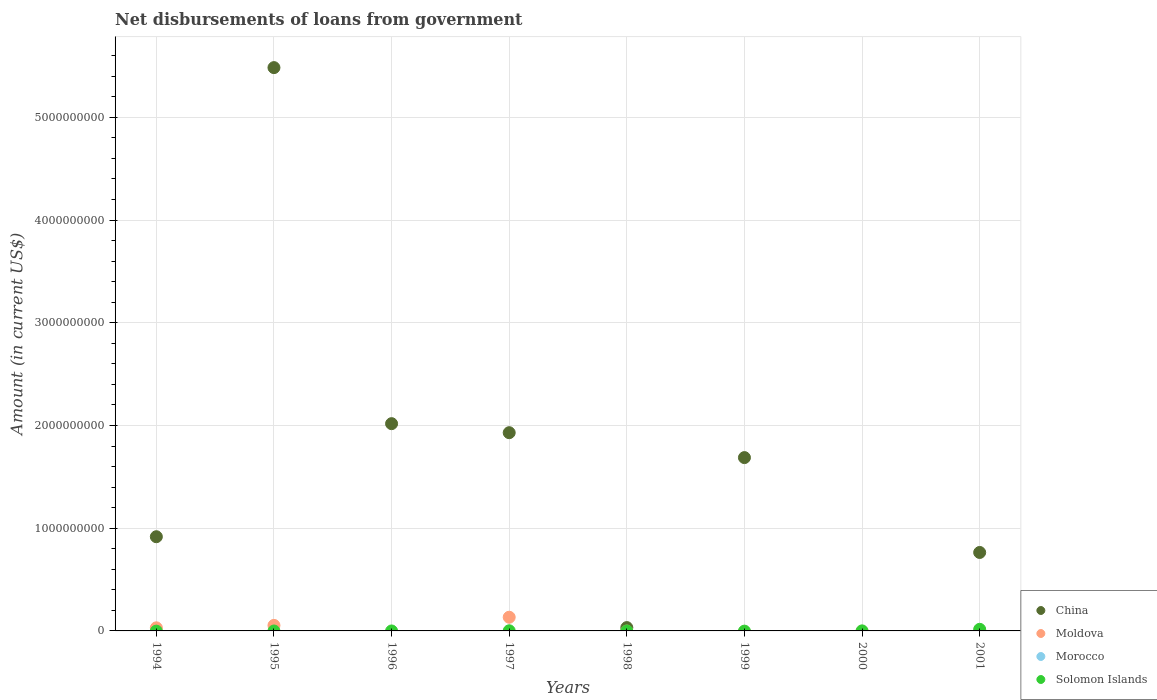Across all years, what is the maximum amount of loan disbursed from government in Moldova?
Provide a succinct answer. 1.33e+08. What is the total amount of loan disbursed from government in Moldova in the graph?
Make the answer very short. 2.17e+08. What is the difference between the amount of loan disbursed from government in Moldova in 1994 and that in 1997?
Make the answer very short. -1.03e+08. What is the difference between the amount of loan disbursed from government in China in 1998 and the amount of loan disbursed from government in Solomon Islands in 1997?
Make the answer very short. 3.10e+07. What is the average amount of loan disbursed from government in Morocco per year?
Your answer should be very brief. 0. In the year 1994, what is the difference between the amount of loan disbursed from government in China and amount of loan disbursed from government in Moldova?
Offer a terse response. 8.87e+08. Is the difference between the amount of loan disbursed from government in China in 1994 and 1997 greater than the difference between the amount of loan disbursed from government in Moldova in 1994 and 1997?
Make the answer very short. No. What is the difference between the highest and the second highest amount of loan disbursed from government in Solomon Islands?
Ensure brevity in your answer.  1.43e+07. What is the difference between the highest and the lowest amount of loan disbursed from government in Solomon Islands?
Your answer should be very brief. 1.57e+07. In how many years, is the amount of loan disbursed from government in China greater than the average amount of loan disbursed from government in China taken over all years?
Offer a terse response. 4. Is it the case that in every year, the sum of the amount of loan disbursed from government in Morocco and amount of loan disbursed from government in China  is greater than the sum of amount of loan disbursed from government in Solomon Islands and amount of loan disbursed from government in Moldova?
Offer a terse response. No. Is the amount of loan disbursed from government in Moldova strictly greater than the amount of loan disbursed from government in Morocco over the years?
Offer a terse response. Yes. Are the values on the major ticks of Y-axis written in scientific E-notation?
Provide a succinct answer. No. How many legend labels are there?
Ensure brevity in your answer.  4. How are the legend labels stacked?
Ensure brevity in your answer.  Vertical. What is the title of the graph?
Your answer should be compact. Net disbursements of loans from government. Does "El Salvador" appear as one of the legend labels in the graph?
Your answer should be compact. No. What is the label or title of the Y-axis?
Offer a terse response. Amount (in current US$). What is the Amount (in current US$) of China in 1994?
Offer a terse response. 9.17e+08. What is the Amount (in current US$) of Moldova in 1994?
Offer a very short reply. 3.01e+07. What is the Amount (in current US$) in Morocco in 1994?
Ensure brevity in your answer.  0. What is the Amount (in current US$) in Solomon Islands in 1994?
Provide a short and direct response. 0. What is the Amount (in current US$) in China in 1995?
Offer a terse response. 5.48e+09. What is the Amount (in current US$) of Moldova in 1995?
Offer a very short reply. 5.38e+07. What is the Amount (in current US$) in Morocco in 1995?
Give a very brief answer. 0. What is the Amount (in current US$) in China in 1996?
Provide a short and direct response. 2.02e+09. What is the Amount (in current US$) in Moldova in 1996?
Your response must be concise. 0. What is the Amount (in current US$) of China in 1997?
Offer a terse response. 1.93e+09. What is the Amount (in current US$) of Moldova in 1997?
Provide a short and direct response. 1.33e+08. What is the Amount (in current US$) in Morocco in 1997?
Your response must be concise. 0. What is the Amount (in current US$) of Solomon Islands in 1997?
Provide a succinct answer. 1.36e+06. What is the Amount (in current US$) of China in 1998?
Your response must be concise. 3.24e+07. What is the Amount (in current US$) of Morocco in 1998?
Your response must be concise. 0. What is the Amount (in current US$) in Solomon Islands in 1998?
Offer a very short reply. 0. What is the Amount (in current US$) in China in 1999?
Offer a terse response. 1.69e+09. What is the Amount (in current US$) of Morocco in 1999?
Ensure brevity in your answer.  0. What is the Amount (in current US$) of Solomon Islands in 1999?
Keep it short and to the point. 0. What is the Amount (in current US$) in China in 2000?
Give a very brief answer. 0. What is the Amount (in current US$) in Moldova in 2000?
Provide a succinct answer. 0. What is the Amount (in current US$) in Solomon Islands in 2000?
Offer a very short reply. 3.48e+05. What is the Amount (in current US$) in China in 2001?
Give a very brief answer. 7.64e+08. What is the Amount (in current US$) in Moldova in 2001?
Ensure brevity in your answer.  0. What is the Amount (in current US$) in Morocco in 2001?
Offer a very short reply. 0. What is the Amount (in current US$) of Solomon Islands in 2001?
Your answer should be compact. 1.57e+07. Across all years, what is the maximum Amount (in current US$) of China?
Give a very brief answer. 5.48e+09. Across all years, what is the maximum Amount (in current US$) of Moldova?
Make the answer very short. 1.33e+08. Across all years, what is the maximum Amount (in current US$) in Solomon Islands?
Provide a succinct answer. 1.57e+07. Across all years, what is the minimum Amount (in current US$) in China?
Offer a very short reply. 0. Across all years, what is the minimum Amount (in current US$) of Solomon Islands?
Your answer should be compact. 0. What is the total Amount (in current US$) of China in the graph?
Offer a terse response. 1.28e+1. What is the total Amount (in current US$) of Moldova in the graph?
Provide a succinct answer. 2.17e+08. What is the total Amount (in current US$) of Morocco in the graph?
Your response must be concise. 0. What is the total Amount (in current US$) of Solomon Islands in the graph?
Offer a terse response. 1.74e+07. What is the difference between the Amount (in current US$) in China in 1994 and that in 1995?
Offer a terse response. -4.57e+09. What is the difference between the Amount (in current US$) of Moldova in 1994 and that in 1995?
Give a very brief answer. -2.38e+07. What is the difference between the Amount (in current US$) of China in 1994 and that in 1996?
Provide a short and direct response. -1.10e+09. What is the difference between the Amount (in current US$) in China in 1994 and that in 1997?
Your answer should be very brief. -1.01e+09. What is the difference between the Amount (in current US$) in Moldova in 1994 and that in 1997?
Your response must be concise. -1.03e+08. What is the difference between the Amount (in current US$) in China in 1994 and that in 1998?
Ensure brevity in your answer.  8.85e+08. What is the difference between the Amount (in current US$) in China in 1994 and that in 1999?
Ensure brevity in your answer.  -7.70e+08. What is the difference between the Amount (in current US$) of China in 1994 and that in 2001?
Your answer should be compact. 1.53e+08. What is the difference between the Amount (in current US$) of China in 1995 and that in 1996?
Give a very brief answer. 3.47e+09. What is the difference between the Amount (in current US$) in China in 1995 and that in 1997?
Make the answer very short. 3.55e+09. What is the difference between the Amount (in current US$) in Moldova in 1995 and that in 1997?
Offer a very short reply. -7.94e+07. What is the difference between the Amount (in current US$) in China in 1995 and that in 1998?
Your answer should be very brief. 5.45e+09. What is the difference between the Amount (in current US$) of China in 1995 and that in 1999?
Provide a short and direct response. 3.80e+09. What is the difference between the Amount (in current US$) in China in 1995 and that in 2001?
Provide a short and direct response. 4.72e+09. What is the difference between the Amount (in current US$) of China in 1996 and that in 1997?
Provide a succinct answer. 8.78e+07. What is the difference between the Amount (in current US$) in China in 1996 and that in 1998?
Make the answer very short. 1.99e+09. What is the difference between the Amount (in current US$) in China in 1996 and that in 1999?
Provide a short and direct response. 3.30e+08. What is the difference between the Amount (in current US$) in China in 1996 and that in 2001?
Give a very brief answer. 1.25e+09. What is the difference between the Amount (in current US$) of China in 1997 and that in 1998?
Offer a terse response. 1.90e+09. What is the difference between the Amount (in current US$) of China in 1997 and that in 1999?
Make the answer very short. 2.43e+08. What is the difference between the Amount (in current US$) of Solomon Islands in 1997 and that in 2000?
Ensure brevity in your answer.  1.01e+06. What is the difference between the Amount (in current US$) of China in 1997 and that in 2001?
Make the answer very short. 1.17e+09. What is the difference between the Amount (in current US$) of Solomon Islands in 1997 and that in 2001?
Provide a short and direct response. -1.43e+07. What is the difference between the Amount (in current US$) of China in 1998 and that in 1999?
Provide a succinct answer. -1.66e+09. What is the difference between the Amount (in current US$) of China in 1998 and that in 2001?
Offer a terse response. -7.31e+08. What is the difference between the Amount (in current US$) of China in 1999 and that in 2001?
Your response must be concise. 9.24e+08. What is the difference between the Amount (in current US$) of Solomon Islands in 2000 and that in 2001?
Provide a succinct answer. -1.53e+07. What is the difference between the Amount (in current US$) of China in 1994 and the Amount (in current US$) of Moldova in 1995?
Your answer should be very brief. 8.63e+08. What is the difference between the Amount (in current US$) in China in 1994 and the Amount (in current US$) in Moldova in 1997?
Your answer should be compact. 7.84e+08. What is the difference between the Amount (in current US$) in China in 1994 and the Amount (in current US$) in Solomon Islands in 1997?
Provide a succinct answer. 9.16e+08. What is the difference between the Amount (in current US$) in Moldova in 1994 and the Amount (in current US$) in Solomon Islands in 1997?
Provide a short and direct response. 2.87e+07. What is the difference between the Amount (in current US$) of China in 1994 and the Amount (in current US$) of Solomon Islands in 2000?
Your answer should be very brief. 9.17e+08. What is the difference between the Amount (in current US$) of Moldova in 1994 and the Amount (in current US$) of Solomon Islands in 2000?
Keep it short and to the point. 2.97e+07. What is the difference between the Amount (in current US$) in China in 1994 and the Amount (in current US$) in Solomon Islands in 2001?
Give a very brief answer. 9.01e+08. What is the difference between the Amount (in current US$) in Moldova in 1994 and the Amount (in current US$) in Solomon Islands in 2001?
Your response must be concise. 1.44e+07. What is the difference between the Amount (in current US$) in China in 1995 and the Amount (in current US$) in Moldova in 1997?
Give a very brief answer. 5.35e+09. What is the difference between the Amount (in current US$) of China in 1995 and the Amount (in current US$) of Solomon Islands in 1997?
Give a very brief answer. 5.48e+09. What is the difference between the Amount (in current US$) of Moldova in 1995 and the Amount (in current US$) of Solomon Islands in 1997?
Give a very brief answer. 5.25e+07. What is the difference between the Amount (in current US$) in China in 1995 and the Amount (in current US$) in Solomon Islands in 2000?
Offer a terse response. 5.48e+09. What is the difference between the Amount (in current US$) in Moldova in 1995 and the Amount (in current US$) in Solomon Islands in 2000?
Make the answer very short. 5.35e+07. What is the difference between the Amount (in current US$) of China in 1995 and the Amount (in current US$) of Solomon Islands in 2001?
Offer a terse response. 5.47e+09. What is the difference between the Amount (in current US$) of Moldova in 1995 and the Amount (in current US$) of Solomon Islands in 2001?
Provide a short and direct response. 3.82e+07. What is the difference between the Amount (in current US$) in China in 1996 and the Amount (in current US$) in Moldova in 1997?
Keep it short and to the point. 1.88e+09. What is the difference between the Amount (in current US$) of China in 1996 and the Amount (in current US$) of Solomon Islands in 1997?
Provide a short and direct response. 2.02e+09. What is the difference between the Amount (in current US$) of China in 1996 and the Amount (in current US$) of Solomon Islands in 2000?
Provide a short and direct response. 2.02e+09. What is the difference between the Amount (in current US$) in China in 1996 and the Amount (in current US$) in Solomon Islands in 2001?
Your answer should be very brief. 2.00e+09. What is the difference between the Amount (in current US$) in China in 1997 and the Amount (in current US$) in Solomon Islands in 2000?
Ensure brevity in your answer.  1.93e+09. What is the difference between the Amount (in current US$) of Moldova in 1997 and the Amount (in current US$) of Solomon Islands in 2000?
Give a very brief answer. 1.33e+08. What is the difference between the Amount (in current US$) of China in 1997 and the Amount (in current US$) of Solomon Islands in 2001?
Keep it short and to the point. 1.91e+09. What is the difference between the Amount (in current US$) of Moldova in 1997 and the Amount (in current US$) of Solomon Islands in 2001?
Keep it short and to the point. 1.18e+08. What is the difference between the Amount (in current US$) in China in 1998 and the Amount (in current US$) in Solomon Islands in 2000?
Your answer should be compact. 3.20e+07. What is the difference between the Amount (in current US$) in China in 1998 and the Amount (in current US$) in Solomon Islands in 2001?
Provide a succinct answer. 1.67e+07. What is the difference between the Amount (in current US$) of China in 1999 and the Amount (in current US$) of Solomon Islands in 2000?
Ensure brevity in your answer.  1.69e+09. What is the difference between the Amount (in current US$) in China in 1999 and the Amount (in current US$) in Solomon Islands in 2001?
Offer a very short reply. 1.67e+09. What is the average Amount (in current US$) of China per year?
Your answer should be compact. 1.60e+09. What is the average Amount (in current US$) of Moldova per year?
Ensure brevity in your answer.  2.71e+07. What is the average Amount (in current US$) of Solomon Islands per year?
Ensure brevity in your answer.  2.17e+06. In the year 1994, what is the difference between the Amount (in current US$) of China and Amount (in current US$) of Moldova?
Your answer should be compact. 8.87e+08. In the year 1995, what is the difference between the Amount (in current US$) of China and Amount (in current US$) of Moldova?
Your response must be concise. 5.43e+09. In the year 1997, what is the difference between the Amount (in current US$) in China and Amount (in current US$) in Moldova?
Provide a short and direct response. 1.80e+09. In the year 1997, what is the difference between the Amount (in current US$) of China and Amount (in current US$) of Solomon Islands?
Your answer should be compact. 1.93e+09. In the year 1997, what is the difference between the Amount (in current US$) in Moldova and Amount (in current US$) in Solomon Islands?
Keep it short and to the point. 1.32e+08. In the year 2001, what is the difference between the Amount (in current US$) in China and Amount (in current US$) in Solomon Islands?
Give a very brief answer. 7.48e+08. What is the ratio of the Amount (in current US$) in China in 1994 to that in 1995?
Keep it short and to the point. 0.17. What is the ratio of the Amount (in current US$) of Moldova in 1994 to that in 1995?
Ensure brevity in your answer.  0.56. What is the ratio of the Amount (in current US$) of China in 1994 to that in 1996?
Your response must be concise. 0.45. What is the ratio of the Amount (in current US$) in China in 1994 to that in 1997?
Offer a terse response. 0.48. What is the ratio of the Amount (in current US$) in Moldova in 1994 to that in 1997?
Provide a short and direct response. 0.23. What is the ratio of the Amount (in current US$) of China in 1994 to that in 1998?
Provide a succinct answer. 28.33. What is the ratio of the Amount (in current US$) of China in 1994 to that in 1999?
Make the answer very short. 0.54. What is the ratio of the Amount (in current US$) in China in 1994 to that in 2001?
Keep it short and to the point. 1.2. What is the ratio of the Amount (in current US$) in China in 1995 to that in 1996?
Your answer should be compact. 2.72. What is the ratio of the Amount (in current US$) in China in 1995 to that in 1997?
Offer a terse response. 2.84. What is the ratio of the Amount (in current US$) in Moldova in 1995 to that in 1997?
Give a very brief answer. 0.4. What is the ratio of the Amount (in current US$) in China in 1995 to that in 1998?
Your answer should be very brief. 169.43. What is the ratio of the Amount (in current US$) in China in 1995 to that in 1999?
Your response must be concise. 3.25. What is the ratio of the Amount (in current US$) of China in 1995 to that in 2001?
Ensure brevity in your answer.  7.18. What is the ratio of the Amount (in current US$) of China in 1996 to that in 1997?
Ensure brevity in your answer.  1.05. What is the ratio of the Amount (in current US$) in China in 1996 to that in 1998?
Ensure brevity in your answer.  62.34. What is the ratio of the Amount (in current US$) of China in 1996 to that in 1999?
Offer a terse response. 1.2. What is the ratio of the Amount (in current US$) of China in 1996 to that in 2001?
Provide a short and direct response. 2.64. What is the ratio of the Amount (in current US$) in China in 1997 to that in 1998?
Keep it short and to the point. 59.63. What is the ratio of the Amount (in current US$) in China in 1997 to that in 1999?
Your answer should be very brief. 1.14. What is the ratio of the Amount (in current US$) in Solomon Islands in 1997 to that in 2000?
Your answer should be compact. 3.9. What is the ratio of the Amount (in current US$) of China in 1997 to that in 2001?
Your response must be concise. 2.53. What is the ratio of the Amount (in current US$) in Solomon Islands in 1997 to that in 2001?
Ensure brevity in your answer.  0.09. What is the ratio of the Amount (in current US$) in China in 1998 to that in 1999?
Provide a succinct answer. 0.02. What is the ratio of the Amount (in current US$) in China in 1998 to that in 2001?
Provide a short and direct response. 0.04. What is the ratio of the Amount (in current US$) of China in 1999 to that in 2001?
Keep it short and to the point. 2.21. What is the ratio of the Amount (in current US$) of Solomon Islands in 2000 to that in 2001?
Offer a very short reply. 0.02. What is the difference between the highest and the second highest Amount (in current US$) of China?
Make the answer very short. 3.47e+09. What is the difference between the highest and the second highest Amount (in current US$) in Moldova?
Provide a succinct answer. 7.94e+07. What is the difference between the highest and the second highest Amount (in current US$) of Solomon Islands?
Your answer should be compact. 1.43e+07. What is the difference between the highest and the lowest Amount (in current US$) of China?
Give a very brief answer. 5.48e+09. What is the difference between the highest and the lowest Amount (in current US$) of Moldova?
Provide a succinct answer. 1.33e+08. What is the difference between the highest and the lowest Amount (in current US$) of Solomon Islands?
Make the answer very short. 1.57e+07. 